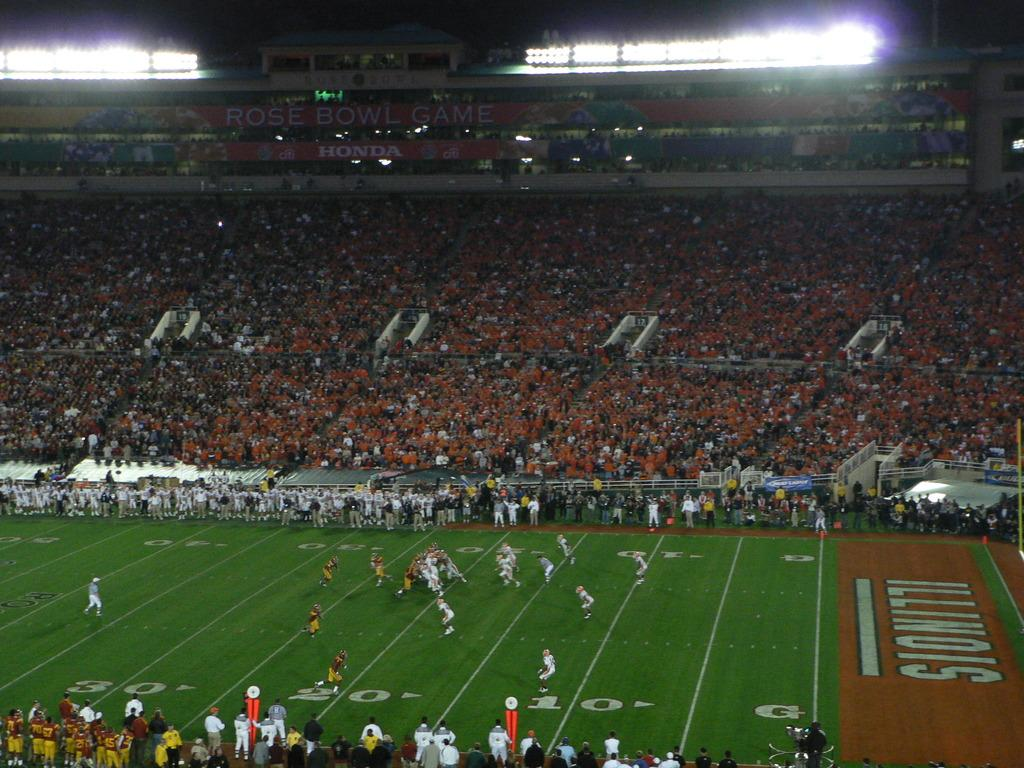<image>
Describe the image concisely. Illinois plays football with a stand full of fans. 